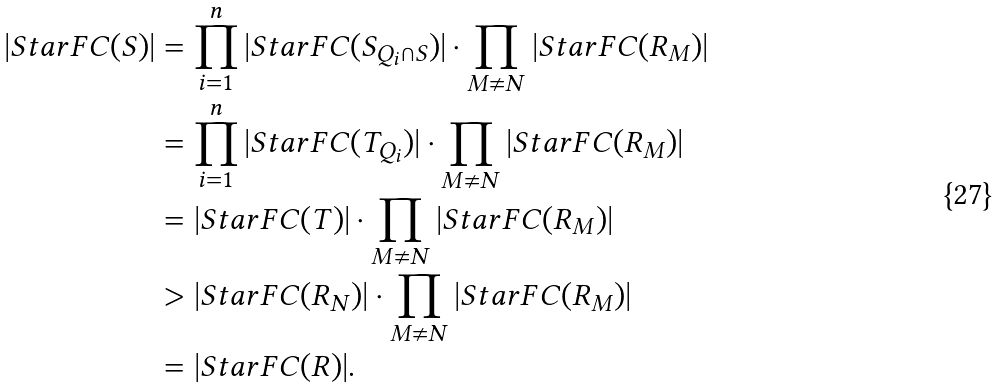<formula> <loc_0><loc_0><loc_500><loc_500>| S t a r F C ( S ) | & = \prod _ { i = 1 } ^ { n } | S t a r F C ( S _ { Q _ { i } \cap S } ) | \cdot \prod _ { M \not = N } | S t a r F C ( R _ { M } ) | \\ & = \prod _ { i = 1 } ^ { n } | S t a r F C ( T _ { Q _ { i } } ) | \cdot \prod _ { M \ne N } | S t a r F C ( R _ { M } ) | \\ & = | S t a r F C ( T ) | \cdot \prod _ { M \ne N } | S t a r F C ( R _ { M } ) | \\ & > | S t a r F C ( R _ { N } ) | \cdot \prod _ { M \ne N } | S t a r F C ( R _ { M } ) | \\ & = | S t a r F C ( R ) | .</formula> 